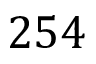<formula> <loc_0><loc_0><loc_500><loc_500>2 5 4</formula> 